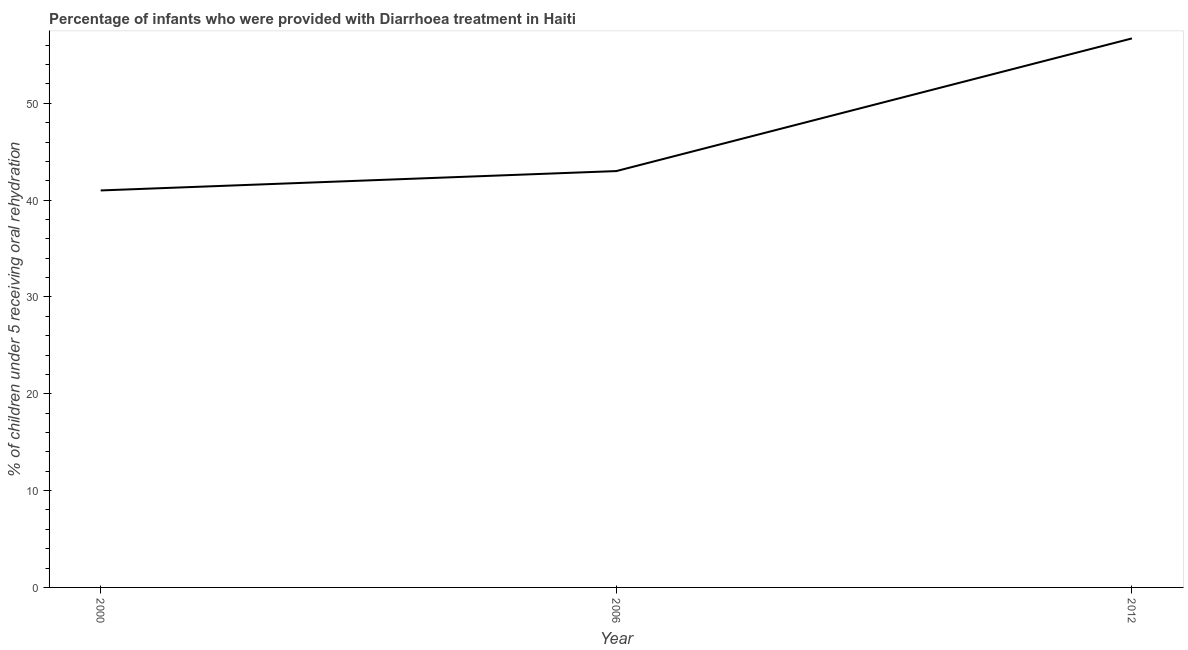What is the percentage of children who were provided with treatment diarrhoea in 2006?
Offer a terse response. 43. Across all years, what is the maximum percentage of children who were provided with treatment diarrhoea?
Make the answer very short. 56.7. In which year was the percentage of children who were provided with treatment diarrhoea maximum?
Your answer should be very brief. 2012. In which year was the percentage of children who were provided with treatment diarrhoea minimum?
Offer a very short reply. 2000. What is the sum of the percentage of children who were provided with treatment diarrhoea?
Give a very brief answer. 140.7. What is the difference between the percentage of children who were provided with treatment diarrhoea in 2006 and 2012?
Offer a very short reply. -13.7. What is the average percentage of children who were provided with treatment diarrhoea per year?
Provide a short and direct response. 46.9. In how many years, is the percentage of children who were provided with treatment diarrhoea greater than 6 %?
Your answer should be compact. 3. What is the ratio of the percentage of children who were provided with treatment diarrhoea in 2000 to that in 2006?
Provide a succinct answer. 0.95. Is the percentage of children who were provided with treatment diarrhoea in 2000 less than that in 2006?
Provide a short and direct response. Yes. Is the difference between the percentage of children who were provided with treatment diarrhoea in 2000 and 2012 greater than the difference between any two years?
Your response must be concise. Yes. What is the difference between the highest and the second highest percentage of children who were provided with treatment diarrhoea?
Provide a succinct answer. 13.7. Is the sum of the percentage of children who were provided with treatment diarrhoea in 2000 and 2012 greater than the maximum percentage of children who were provided with treatment diarrhoea across all years?
Your answer should be very brief. Yes. What is the difference between the highest and the lowest percentage of children who were provided with treatment diarrhoea?
Ensure brevity in your answer.  15.7. Does the percentage of children who were provided with treatment diarrhoea monotonically increase over the years?
Ensure brevity in your answer.  Yes. How many lines are there?
Ensure brevity in your answer.  1. How many years are there in the graph?
Keep it short and to the point. 3. What is the difference between two consecutive major ticks on the Y-axis?
Provide a short and direct response. 10. Does the graph contain any zero values?
Provide a succinct answer. No. What is the title of the graph?
Keep it short and to the point. Percentage of infants who were provided with Diarrhoea treatment in Haiti. What is the label or title of the X-axis?
Ensure brevity in your answer.  Year. What is the label or title of the Y-axis?
Offer a very short reply. % of children under 5 receiving oral rehydration. What is the % of children under 5 receiving oral rehydration in 2000?
Your answer should be very brief. 41. What is the % of children under 5 receiving oral rehydration in 2006?
Your answer should be compact. 43. What is the % of children under 5 receiving oral rehydration of 2012?
Provide a succinct answer. 56.7. What is the difference between the % of children under 5 receiving oral rehydration in 2000 and 2012?
Make the answer very short. -15.7. What is the difference between the % of children under 5 receiving oral rehydration in 2006 and 2012?
Provide a succinct answer. -13.7. What is the ratio of the % of children under 5 receiving oral rehydration in 2000 to that in 2006?
Your response must be concise. 0.95. What is the ratio of the % of children under 5 receiving oral rehydration in 2000 to that in 2012?
Your response must be concise. 0.72. What is the ratio of the % of children under 5 receiving oral rehydration in 2006 to that in 2012?
Your answer should be very brief. 0.76. 